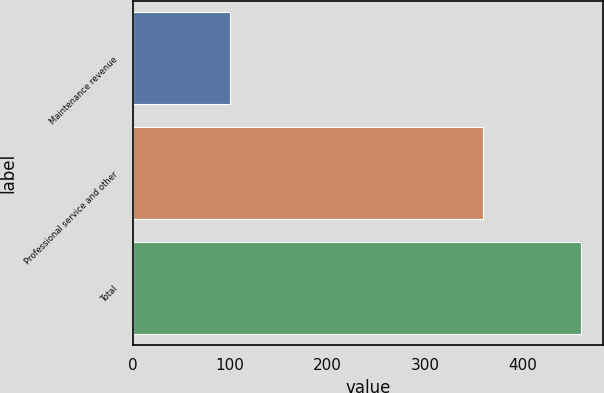Convert chart to OTSL. <chart><loc_0><loc_0><loc_500><loc_500><bar_chart><fcel>Maintenance revenue<fcel>Professional service and other<fcel>Total<nl><fcel>100.4<fcel>359.6<fcel>460<nl></chart> 